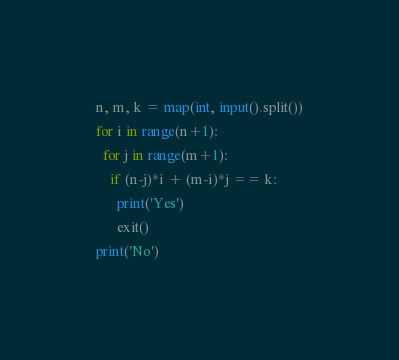<code> <loc_0><loc_0><loc_500><loc_500><_Python_>n, m, k = map(int, input().split())
for i in range(n+1):
  for j in range(m+1):
    if (n-j)*i + (m-i)*j == k:
      print('Yes')
      exit()
print('No')</code> 